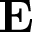<formula> <loc_0><loc_0><loc_500><loc_500>E</formula> 